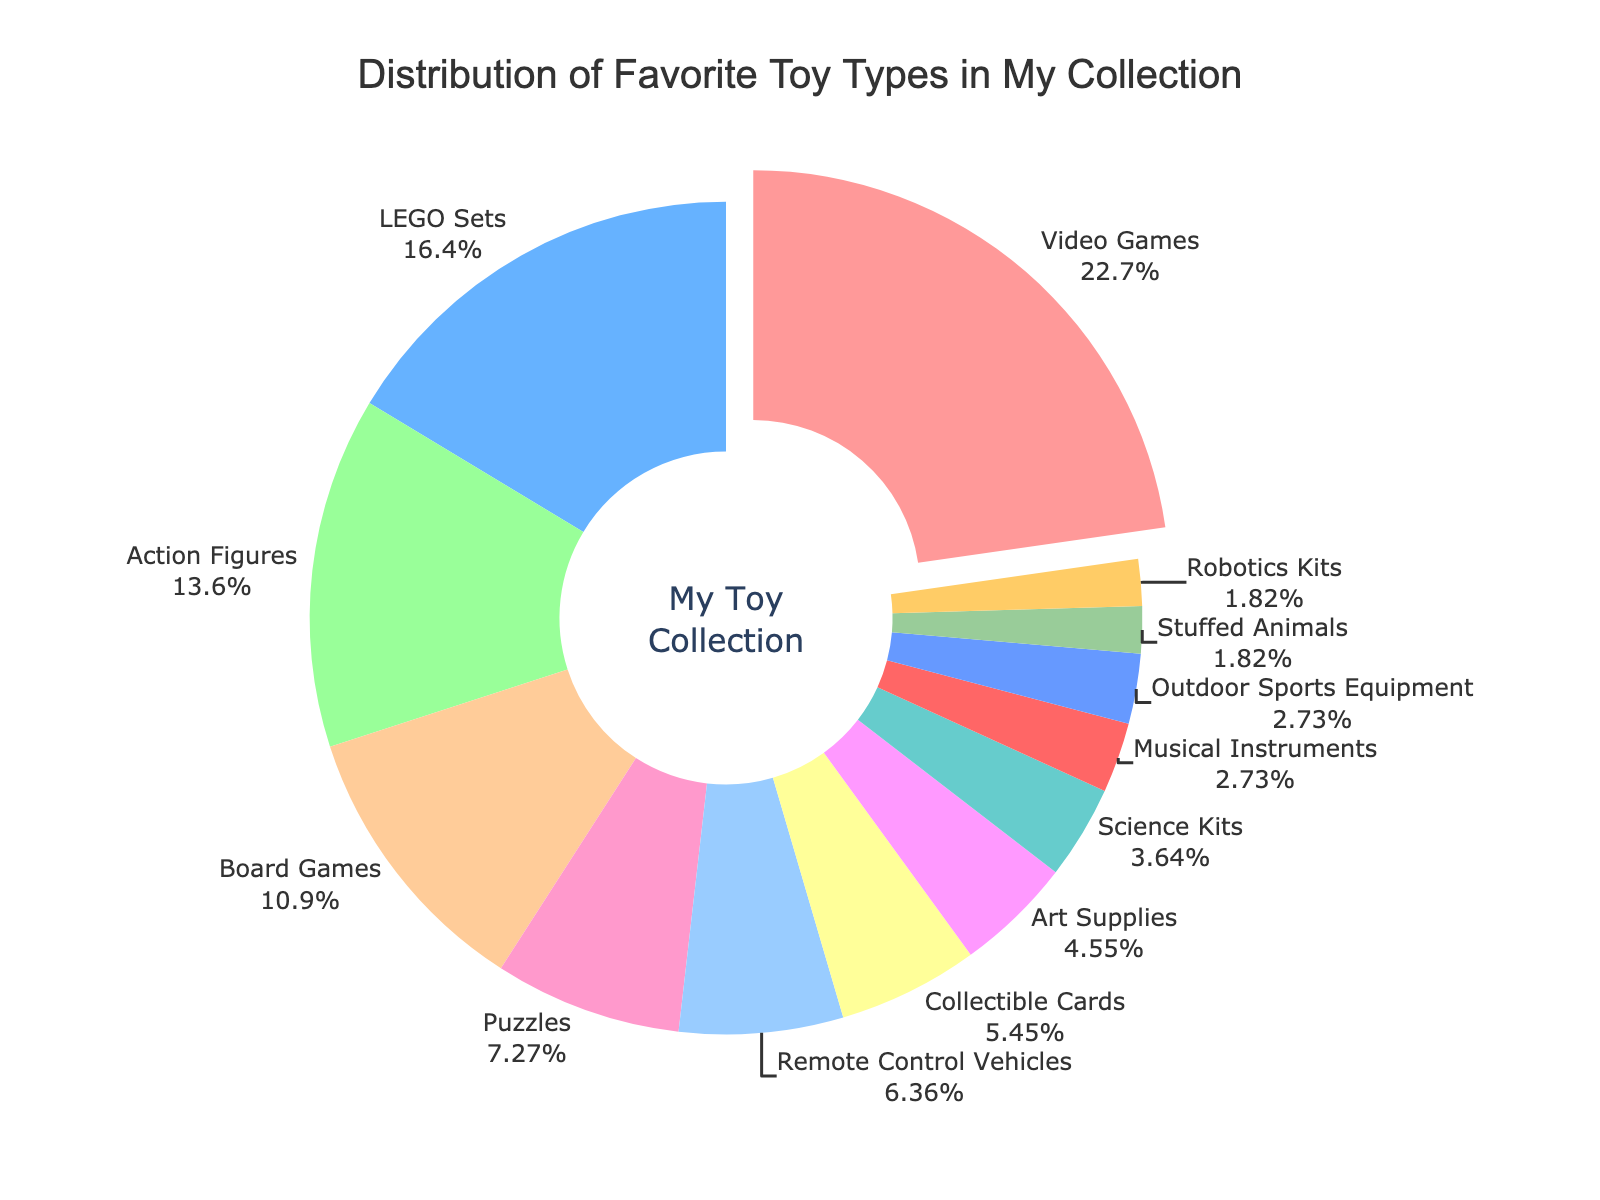what is the most common toy type in the collection? The largest section of the pie chart, which is pulled out slightly, indicates the most common toy type. From the text labels, it is clear that the largest section represents Video Games.
Answer: Video Games what percentage of the collection is made up of LEGO Sets? By looking at the pie chart section labeled LEGO Sets, you can see the percentage value provided.
Answer: 18% comparing Board Games and Action Figures, which toy type occupies a larger portion of the collection? Both sections are labeled in the pie chart, allowing us to compare their percentages directly. Action Figures have 15%, while Board Games have 12%.
Answer: Action Figures how much larger is the percentage of Video Games compared to the percentage of Science Kits? Video Games constitute 25%, while Science Kits make up 4%. Subtracting these values gives the difference. 25% - 4% = 21%.
Answer: 21% what is the combined percentage of Art Supplies and Stuffed Animals? Art Supplies constitute 5% and Stuffed Animals constitute 2%. Adding these percentages gives the combined total. 5% + 2% = 7%.
Answer: 7% which color represents Remote Control Vehicles in the pie chart? By examining the color legend associated with Remote Control Vehicles' label, we find that it is a light orange-pink color.
Answer: light orange-pink how many toy types each make up less than 5% of the collection? By examining the chart, we identify toys that have percentages listed as less than 5% which are Science Kits, Musical Instruments, Outdoor Sports Equipment, Stuffed Animals, and Robotics Kits.
Answer: 5 what is the total percentage of Puzzles, Collectible Cards, and Art Supplies combined? The pie chart segments show Puzzles at 8%, Collectible Cards at 6%, and Art Supplies at 5%. Adding these together: 8% + 6% + 5% = 19%.
Answer: 19% which toy type is represented by the smallest segment in the chart? The smallest section of the pie chart is the one labeled 2%, which corresponds to Stuffed Animals and Robotics Kits. However, both have the same percentage, so either can be the answer.
Answer: Stuffed Animals or Robotics Kits what toy type has a higher percentage than Action Figures but a lower percentage than Video Games? By comparing percentages, LEGO Sets, which is marked at 18%, is between the percentage of Action Figures (15%) and Video Games (25%).
Answer: LEGO Sets 